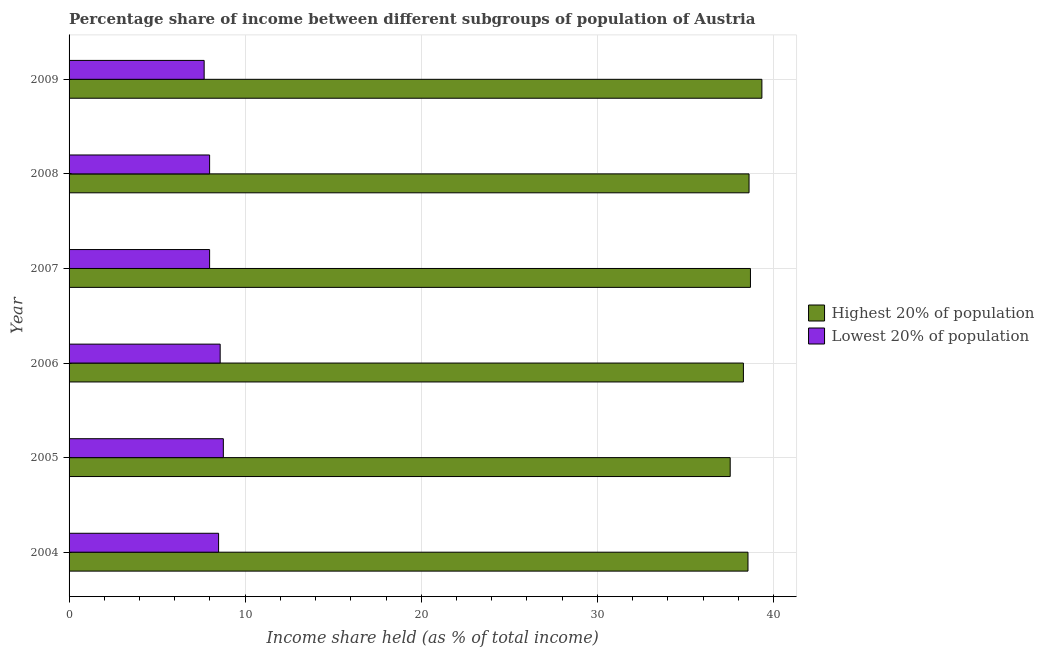Are the number of bars on each tick of the Y-axis equal?
Keep it short and to the point. Yes. What is the label of the 6th group of bars from the top?
Offer a very short reply. 2004. In how many cases, is the number of bars for a given year not equal to the number of legend labels?
Offer a very short reply. 0. What is the income share held by highest 20% of the population in 2009?
Your answer should be compact. 39.34. Across all years, what is the maximum income share held by highest 20% of the population?
Ensure brevity in your answer.  39.34. Across all years, what is the minimum income share held by highest 20% of the population?
Offer a very short reply. 37.54. In which year was the income share held by lowest 20% of the population minimum?
Ensure brevity in your answer.  2009. What is the total income share held by lowest 20% of the population in the graph?
Provide a short and direct response. 49.46. What is the difference between the income share held by highest 20% of the population in 2005 and that in 2007?
Provide a succinct answer. -1.15. What is the difference between the income share held by highest 20% of the population in 2005 and the income share held by lowest 20% of the population in 2007?
Keep it short and to the point. 29.56. What is the average income share held by lowest 20% of the population per year?
Your answer should be compact. 8.24. In the year 2009, what is the difference between the income share held by lowest 20% of the population and income share held by highest 20% of the population?
Offer a terse response. -31.67. What is the ratio of the income share held by lowest 20% of the population in 2006 to that in 2008?
Ensure brevity in your answer.  1.07. What is the difference between the highest and the second highest income share held by highest 20% of the population?
Make the answer very short. 0.65. What is the difference between the highest and the lowest income share held by lowest 20% of the population?
Your answer should be compact. 1.09. In how many years, is the income share held by highest 20% of the population greater than the average income share held by highest 20% of the population taken over all years?
Provide a short and direct response. 4. What does the 1st bar from the top in 2007 represents?
Offer a very short reply. Lowest 20% of population. What does the 1st bar from the bottom in 2004 represents?
Give a very brief answer. Highest 20% of population. How many bars are there?
Provide a short and direct response. 12. How many years are there in the graph?
Provide a succinct answer. 6. What is the difference between two consecutive major ticks on the X-axis?
Provide a succinct answer. 10. Does the graph contain any zero values?
Offer a terse response. No. Does the graph contain grids?
Make the answer very short. Yes. Where does the legend appear in the graph?
Offer a terse response. Center right. How many legend labels are there?
Offer a very short reply. 2. How are the legend labels stacked?
Offer a terse response. Vertical. What is the title of the graph?
Your answer should be compact. Percentage share of income between different subgroups of population of Austria. Does "current US$" appear as one of the legend labels in the graph?
Your answer should be compact. No. What is the label or title of the X-axis?
Your answer should be compact. Income share held (as % of total income). What is the label or title of the Y-axis?
Your response must be concise. Year. What is the Income share held (as % of total income) in Highest 20% of population in 2004?
Your answer should be compact. 38.55. What is the Income share held (as % of total income) in Lowest 20% of population in 2004?
Provide a succinct answer. 8.49. What is the Income share held (as % of total income) of Highest 20% of population in 2005?
Give a very brief answer. 37.54. What is the Income share held (as % of total income) in Lowest 20% of population in 2005?
Make the answer very short. 8.76. What is the Income share held (as % of total income) of Highest 20% of population in 2006?
Your answer should be compact. 38.29. What is the Income share held (as % of total income) in Lowest 20% of population in 2006?
Give a very brief answer. 8.58. What is the Income share held (as % of total income) in Highest 20% of population in 2007?
Your response must be concise. 38.69. What is the Income share held (as % of total income) of Lowest 20% of population in 2007?
Give a very brief answer. 7.98. What is the Income share held (as % of total income) in Highest 20% of population in 2008?
Your response must be concise. 38.61. What is the Income share held (as % of total income) in Lowest 20% of population in 2008?
Provide a short and direct response. 7.98. What is the Income share held (as % of total income) of Highest 20% of population in 2009?
Your answer should be compact. 39.34. What is the Income share held (as % of total income) in Lowest 20% of population in 2009?
Provide a succinct answer. 7.67. Across all years, what is the maximum Income share held (as % of total income) in Highest 20% of population?
Provide a succinct answer. 39.34. Across all years, what is the maximum Income share held (as % of total income) of Lowest 20% of population?
Offer a very short reply. 8.76. Across all years, what is the minimum Income share held (as % of total income) of Highest 20% of population?
Provide a succinct answer. 37.54. Across all years, what is the minimum Income share held (as % of total income) in Lowest 20% of population?
Offer a terse response. 7.67. What is the total Income share held (as % of total income) in Highest 20% of population in the graph?
Your answer should be very brief. 231.02. What is the total Income share held (as % of total income) in Lowest 20% of population in the graph?
Ensure brevity in your answer.  49.46. What is the difference between the Income share held (as % of total income) of Lowest 20% of population in 2004 and that in 2005?
Give a very brief answer. -0.27. What is the difference between the Income share held (as % of total income) of Highest 20% of population in 2004 and that in 2006?
Provide a succinct answer. 0.26. What is the difference between the Income share held (as % of total income) of Lowest 20% of population in 2004 and that in 2006?
Offer a terse response. -0.09. What is the difference between the Income share held (as % of total income) of Highest 20% of population in 2004 and that in 2007?
Provide a short and direct response. -0.14. What is the difference between the Income share held (as % of total income) of Lowest 20% of population in 2004 and that in 2007?
Provide a short and direct response. 0.51. What is the difference between the Income share held (as % of total income) of Highest 20% of population in 2004 and that in 2008?
Provide a succinct answer. -0.06. What is the difference between the Income share held (as % of total income) in Lowest 20% of population in 2004 and that in 2008?
Your answer should be compact. 0.51. What is the difference between the Income share held (as % of total income) of Highest 20% of population in 2004 and that in 2009?
Keep it short and to the point. -0.79. What is the difference between the Income share held (as % of total income) in Lowest 20% of population in 2004 and that in 2009?
Provide a short and direct response. 0.82. What is the difference between the Income share held (as % of total income) of Highest 20% of population in 2005 and that in 2006?
Provide a succinct answer. -0.75. What is the difference between the Income share held (as % of total income) in Lowest 20% of population in 2005 and that in 2006?
Provide a succinct answer. 0.18. What is the difference between the Income share held (as % of total income) of Highest 20% of population in 2005 and that in 2007?
Provide a succinct answer. -1.15. What is the difference between the Income share held (as % of total income) of Lowest 20% of population in 2005 and that in 2007?
Make the answer very short. 0.78. What is the difference between the Income share held (as % of total income) in Highest 20% of population in 2005 and that in 2008?
Your answer should be very brief. -1.07. What is the difference between the Income share held (as % of total income) in Lowest 20% of population in 2005 and that in 2008?
Ensure brevity in your answer.  0.78. What is the difference between the Income share held (as % of total income) of Highest 20% of population in 2005 and that in 2009?
Your answer should be compact. -1.8. What is the difference between the Income share held (as % of total income) of Lowest 20% of population in 2005 and that in 2009?
Make the answer very short. 1.09. What is the difference between the Income share held (as % of total income) of Highest 20% of population in 2006 and that in 2007?
Make the answer very short. -0.4. What is the difference between the Income share held (as % of total income) of Lowest 20% of population in 2006 and that in 2007?
Your answer should be very brief. 0.6. What is the difference between the Income share held (as % of total income) in Highest 20% of population in 2006 and that in 2008?
Your answer should be very brief. -0.32. What is the difference between the Income share held (as % of total income) of Lowest 20% of population in 2006 and that in 2008?
Offer a terse response. 0.6. What is the difference between the Income share held (as % of total income) in Highest 20% of population in 2006 and that in 2009?
Keep it short and to the point. -1.05. What is the difference between the Income share held (as % of total income) of Lowest 20% of population in 2006 and that in 2009?
Your answer should be compact. 0.91. What is the difference between the Income share held (as % of total income) of Highest 20% of population in 2007 and that in 2009?
Make the answer very short. -0.65. What is the difference between the Income share held (as % of total income) of Lowest 20% of population in 2007 and that in 2009?
Your response must be concise. 0.31. What is the difference between the Income share held (as % of total income) of Highest 20% of population in 2008 and that in 2009?
Offer a very short reply. -0.73. What is the difference between the Income share held (as % of total income) in Lowest 20% of population in 2008 and that in 2009?
Keep it short and to the point. 0.31. What is the difference between the Income share held (as % of total income) of Highest 20% of population in 2004 and the Income share held (as % of total income) of Lowest 20% of population in 2005?
Your response must be concise. 29.79. What is the difference between the Income share held (as % of total income) of Highest 20% of population in 2004 and the Income share held (as % of total income) of Lowest 20% of population in 2006?
Your response must be concise. 29.97. What is the difference between the Income share held (as % of total income) of Highest 20% of population in 2004 and the Income share held (as % of total income) of Lowest 20% of population in 2007?
Your response must be concise. 30.57. What is the difference between the Income share held (as % of total income) of Highest 20% of population in 2004 and the Income share held (as % of total income) of Lowest 20% of population in 2008?
Provide a short and direct response. 30.57. What is the difference between the Income share held (as % of total income) in Highest 20% of population in 2004 and the Income share held (as % of total income) in Lowest 20% of population in 2009?
Your answer should be compact. 30.88. What is the difference between the Income share held (as % of total income) of Highest 20% of population in 2005 and the Income share held (as % of total income) of Lowest 20% of population in 2006?
Provide a succinct answer. 28.96. What is the difference between the Income share held (as % of total income) in Highest 20% of population in 2005 and the Income share held (as % of total income) in Lowest 20% of population in 2007?
Offer a very short reply. 29.56. What is the difference between the Income share held (as % of total income) in Highest 20% of population in 2005 and the Income share held (as % of total income) in Lowest 20% of population in 2008?
Make the answer very short. 29.56. What is the difference between the Income share held (as % of total income) of Highest 20% of population in 2005 and the Income share held (as % of total income) of Lowest 20% of population in 2009?
Provide a succinct answer. 29.87. What is the difference between the Income share held (as % of total income) in Highest 20% of population in 2006 and the Income share held (as % of total income) in Lowest 20% of population in 2007?
Make the answer very short. 30.31. What is the difference between the Income share held (as % of total income) of Highest 20% of population in 2006 and the Income share held (as % of total income) of Lowest 20% of population in 2008?
Keep it short and to the point. 30.31. What is the difference between the Income share held (as % of total income) in Highest 20% of population in 2006 and the Income share held (as % of total income) in Lowest 20% of population in 2009?
Offer a very short reply. 30.62. What is the difference between the Income share held (as % of total income) of Highest 20% of population in 2007 and the Income share held (as % of total income) of Lowest 20% of population in 2008?
Offer a terse response. 30.71. What is the difference between the Income share held (as % of total income) in Highest 20% of population in 2007 and the Income share held (as % of total income) in Lowest 20% of population in 2009?
Ensure brevity in your answer.  31.02. What is the difference between the Income share held (as % of total income) in Highest 20% of population in 2008 and the Income share held (as % of total income) in Lowest 20% of population in 2009?
Your answer should be compact. 30.94. What is the average Income share held (as % of total income) in Highest 20% of population per year?
Keep it short and to the point. 38.5. What is the average Income share held (as % of total income) of Lowest 20% of population per year?
Keep it short and to the point. 8.24. In the year 2004, what is the difference between the Income share held (as % of total income) in Highest 20% of population and Income share held (as % of total income) in Lowest 20% of population?
Provide a short and direct response. 30.06. In the year 2005, what is the difference between the Income share held (as % of total income) of Highest 20% of population and Income share held (as % of total income) of Lowest 20% of population?
Your response must be concise. 28.78. In the year 2006, what is the difference between the Income share held (as % of total income) of Highest 20% of population and Income share held (as % of total income) of Lowest 20% of population?
Provide a short and direct response. 29.71. In the year 2007, what is the difference between the Income share held (as % of total income) in Highest 20% of population and Income share held (as % of total income) in Lowest 20% of population?
Your response must be concise. 30.71. In the year 2008, what is the difference between the Income share held (as % of total income) of Highest 20% of population and Income share held (as % of total income) of Lowest 20% of population?
Offer a terse response. 30.63. In the year 2009, what is the difference between the Income share held (as % of total income) in Highest 20% of population and Income share held (as % of total income) in Lowest 20% of population?
Offer a very short reply. 31.67. What is the ratio of the Income share held (as % of total income) of Highest 20% of population in 2004 to that in 2005?
Provide a short and direct response. 1.03. What is the ratio of the Income share held (as % of total income) in Lowest 20% of population in 2004 to that in 2005?
Make the answer very short. 0.97. What is the ratio of the Income share held (as % of total income) of Highest 20% of population in 2004 to that in 2006?
Your response must be concise. 1.01. What is the ratio of the Income share held (as % of total income) of Lowest 20% of population in 2004 to that in 2006?
Provide a succinct answer. 0.99. What is the ratio of the Income share held (as % of total income) in Highest 20% of population in 2004 to that in 2007?
Provide a short and direct response. 1. What is the ratio of the Income share held (as % of total income) of Lowest 20% of population in 2004 to that in 2007?
Your answer should be compact. 1.06. What is the ratio of the Income share held (as % of total income) in Highest 20% of population in 2004 to that in 2008?
Your answer should be very brief. 1. What is the ratio of the Income share held (as % of total income) of Lowest 20% of population in 2004 to that in 2008?
Your answer should be compact. 1.06. What is the ratio of the Income share held (as % of total income) of Highest 20% of population in 2004 to that in 2009?
Offer a terse response. 0.98. What is the ratio of the Income share held (as % of total income) in Lowest 20% of population in 2004 to that in 2009?
Keep it short and to the point. 1.11. What is the ratio of the Income share held (as % of total income) of Highest 20% of population in 2005 to that in 2006?
Keep it short and to the point. 0.98. What is the ratio of the Income share held (as % of total income) of Lowest 20% of population in 2005 to that in 2006?
Give a very brief answer. 1.02. What is the ratio of the Income share held (as % of total income) of Highest 20% of population in 2005 to that in 2007?
Offer a very short reply. 0.97. What is the ratio of the Income share held (as % of total income) of Lowest 20% of population in 2005 to that in 2007?
Your answer should be compact. 1.1. What is the ratio of the Income share held (as % of total income) in Highest 20% of population in 2005 to that in 2008?
Make the answer very short. 0.97. What is the ratio of the Income share held (as % of total income) in Lowest 20% of population in 2005 to that in 2008?
Your response must be concise. 1.1. What is the ratio of the Income share held (as % of total income) of Highest 20% of population in 2005 to that in 2009?
Offer a terse response. 0.95. What is the ratio of the Income share held (as % of total income) in Lowest 20% of population in 2005 to that in 2009?
Offer a very short reply. 1.14. What is the ratio of the Income share held (as % of total income) of Lowest 20% of population in 2006 to that in 2007?
Your answer should be very brief. 1.08. What is the ratio of the Income share held (as % of total income) of Lowest 20% of population in 2006 to that in 2008?
Give a very brief answer. 1.08. What is the ratio of the Income share held (as % of total income) of Highest 20% of population in 2006 to that in 2009?
Your answer should be compact. 0.97. What is the ratio of the Income share held (as % of total income) of Lowest 20% of population in 2006 to that in 2009?
Your response must be concise. 1.12. What is the ratio of the Income share held (as % of total income) in Highest 20% of population in 2007 to that in 2008?
Provide a short and direct response. 1. What is the ratio of the Income share held (as % of total income) of Lowest 20% of population in 2007 to that in 2008?
Keep it short and to the point. 1. What is the ratio of the Income share held (as % of total income) of Highest 20% of population in 2007 to that in 2009?
Your answer should be very brief. 0.98. What is the ratio of the Income share held (as % of total income) of Lowest 20% of population in 2007 to that in 2009?
Offer a terse response. 1.04. What is the ratio of the Income share held (as % of total income) of Highest 20% of population in 2008 to that in 2009?
Offer a very short reply. 0.98. What is the ratio of the Income share held (as % of total income) of Lowest 20% of population in 2008 to that in 2009?
Provide a succinct answer. 1.04. What is the difference between the highest and the second highest Income share held (as % of total income) of Highest 20% of population?
Provide a succinct answer. 0.65. What is the difference between the highest and the second highest Income share held (as % of total income) of Lowest 20% of population?
Offer a very short reply. 0.18. What is the difference between the highest and the lowest Income share held (as % of total income) of Lowest 20% of population?
Ensure brevity in your answer.  1.09. 